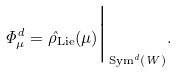<formula> <loc_0><loc_0><loc_500><loc_500>\Phi ^ { d } _ { \mu } = \hat { \rho } _ { \text {Lie} } ( \mu ) \Big | _ { \text {Sym} ^ { d } ( W ) } .</formula> 